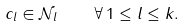<formula> <loc_0><loc_0><loc_500><loc_500>c _ { l } \in \mathcal { N } _ { l } \quad \forall \, 1 \leq l \leq k .</formula> 